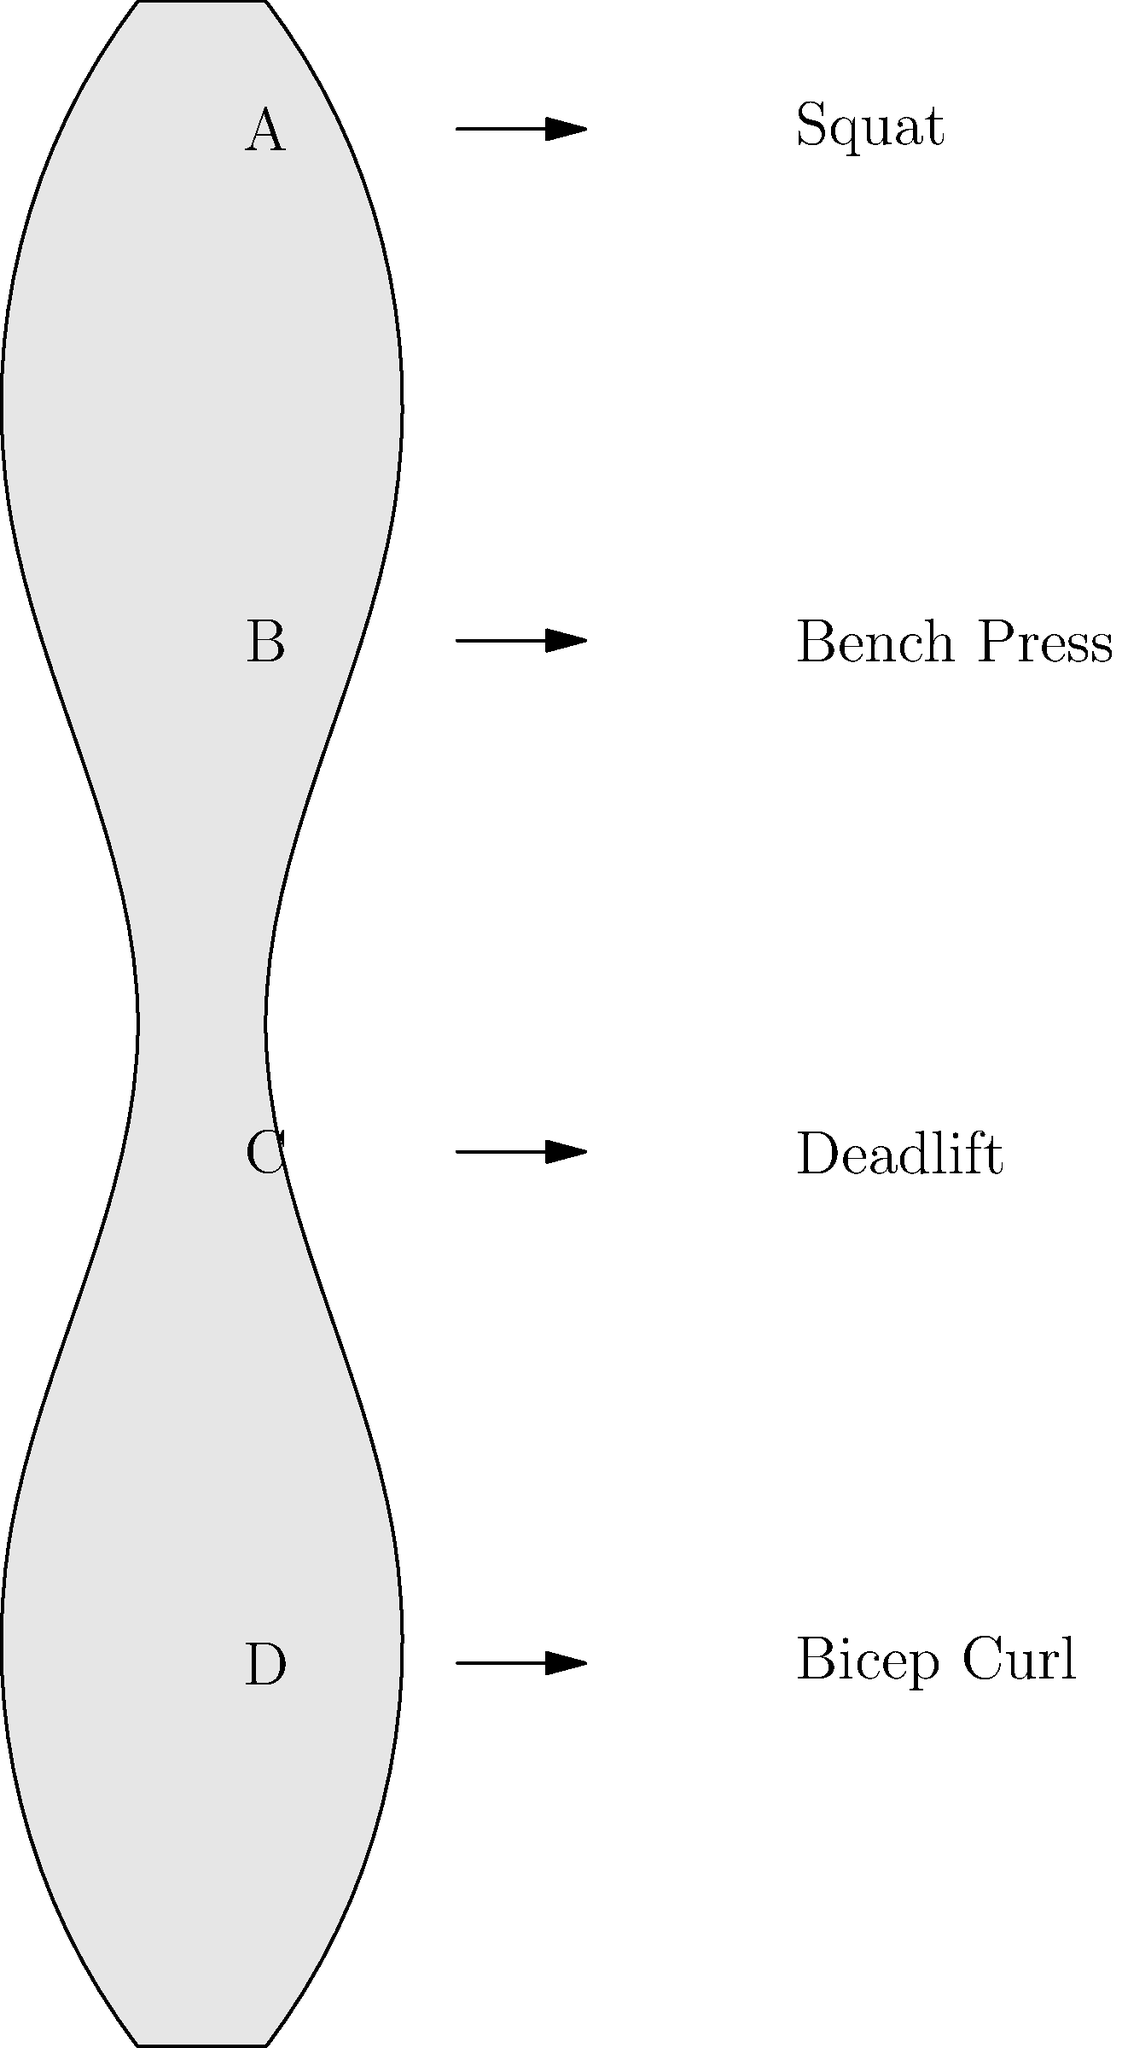As a sports academy staff member working with young athletes, you're tasked with evaluating muscle group engagement during different exercises. Using the human body diagram provided, match the labeled muscle groups (A, B, C, D) with the exercise that primarily engages each group. Which muscle group is most engaged during a deadlift, and why is this exercise particularly important for athletes transitioning to professional careers? To answer this question, let's break down the muscle groups and exercises:

1. Muscle group identification:
   A: Shoulders and upper back
   B: Chest
   C: Lower back and core
   D: Arms (biceps)

2. Exercise and primary muscle group engagement:
   Squat: Primarily engages legs and core (not shown in diagram)
   Bench Press: Primarily engages chest (B)
   Deadlift: Primarily engages lower back and core (C)
   Bicep Curl: Primarily engages arms, specifically biceps (D)

3. The deadlift primarily engages muscle group C (lower back and core).

4. Importance of deadlifts for transitioning athletes:
   a) Compound movement: Engages multiple muscle groups simultaneously
   b) Functional strength: Mimics real-world movements and sports actions
   c) Core stability: Develops a strong foundation for all athletic movements
   d) Injury prevention: Strengthens the posterior chain, reducing injury risk
   e) Power development: Improves explosive strength for various sports
   f) Hormonal benefits: Stimulates growth hormone and testosterone production

The deadlift is crucial for athletes transitioning to professional careers because it develops overall strength, power, and stability, which are fundamental for high-level performance across various sports.
Answer: Muscle group C (lower back and core); deadlifts develop functional strength, power, and stability crucial for professional athletic performance. 